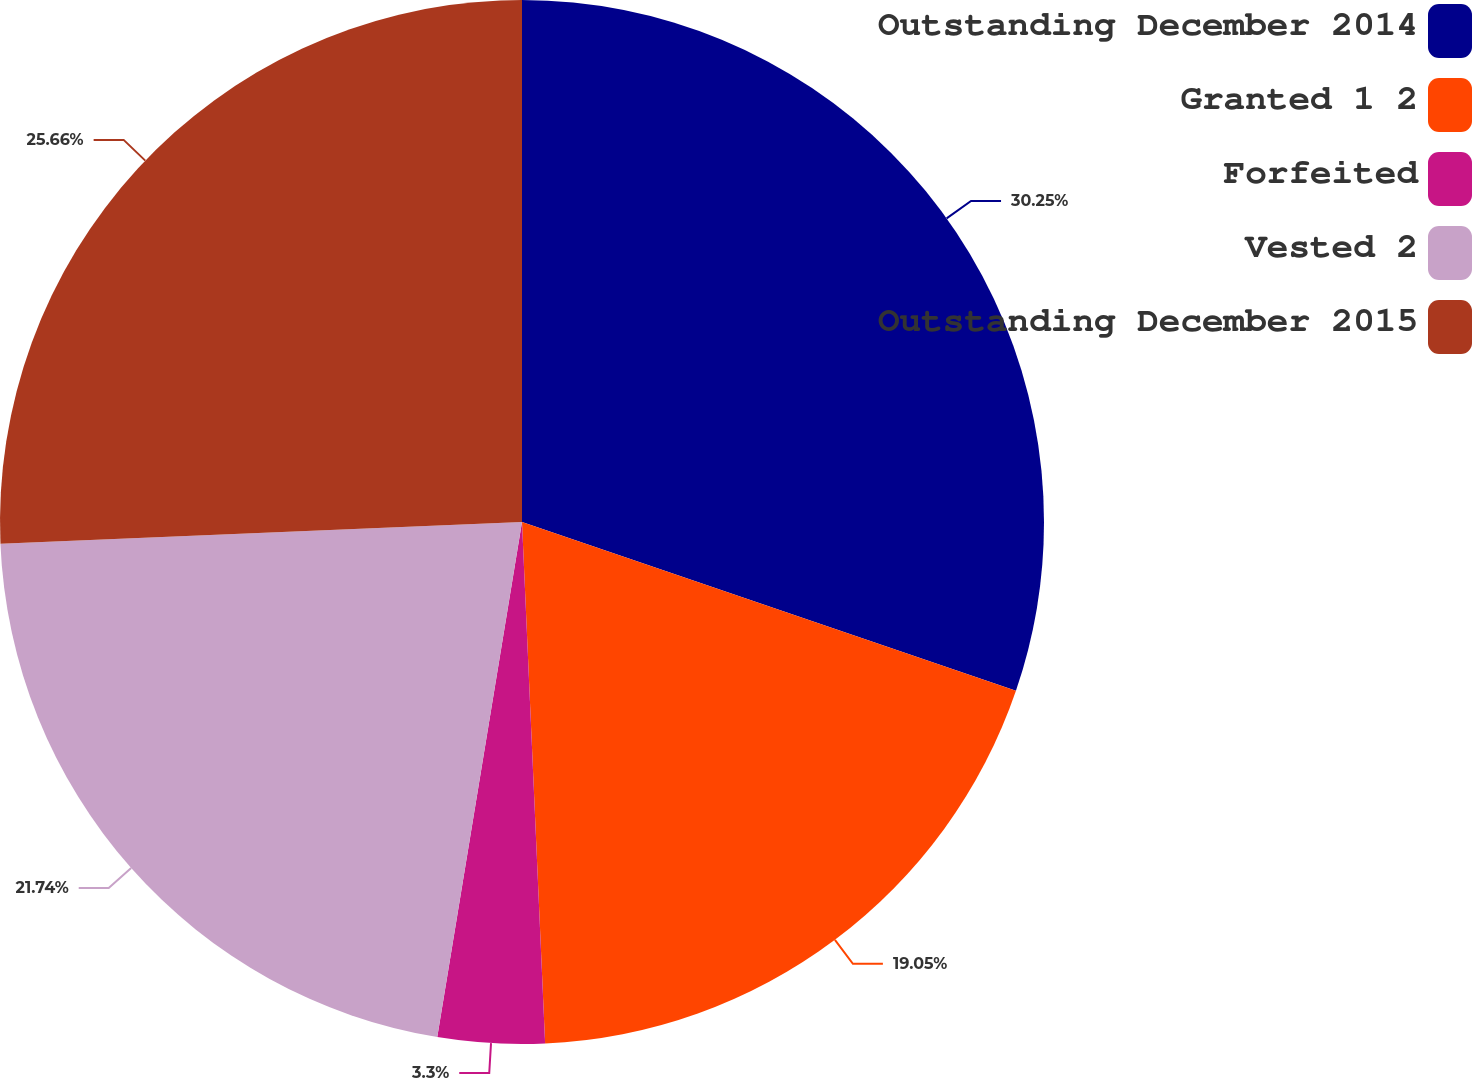Convert chart to OTSL. <chart><loc_0><loc_0><loc_500><loc_500><pie_chart><fcel>Outstanding December 2014<fcel>Granted 1 2<fcel>Forfeited<fcel>Vested 2<fcel>Outstanding December 2015<nl><fcel>30.24%<fcel>19.05%<fcel>3.3%<fcel>21.74%<fcel>25.66%<nl></chart> 